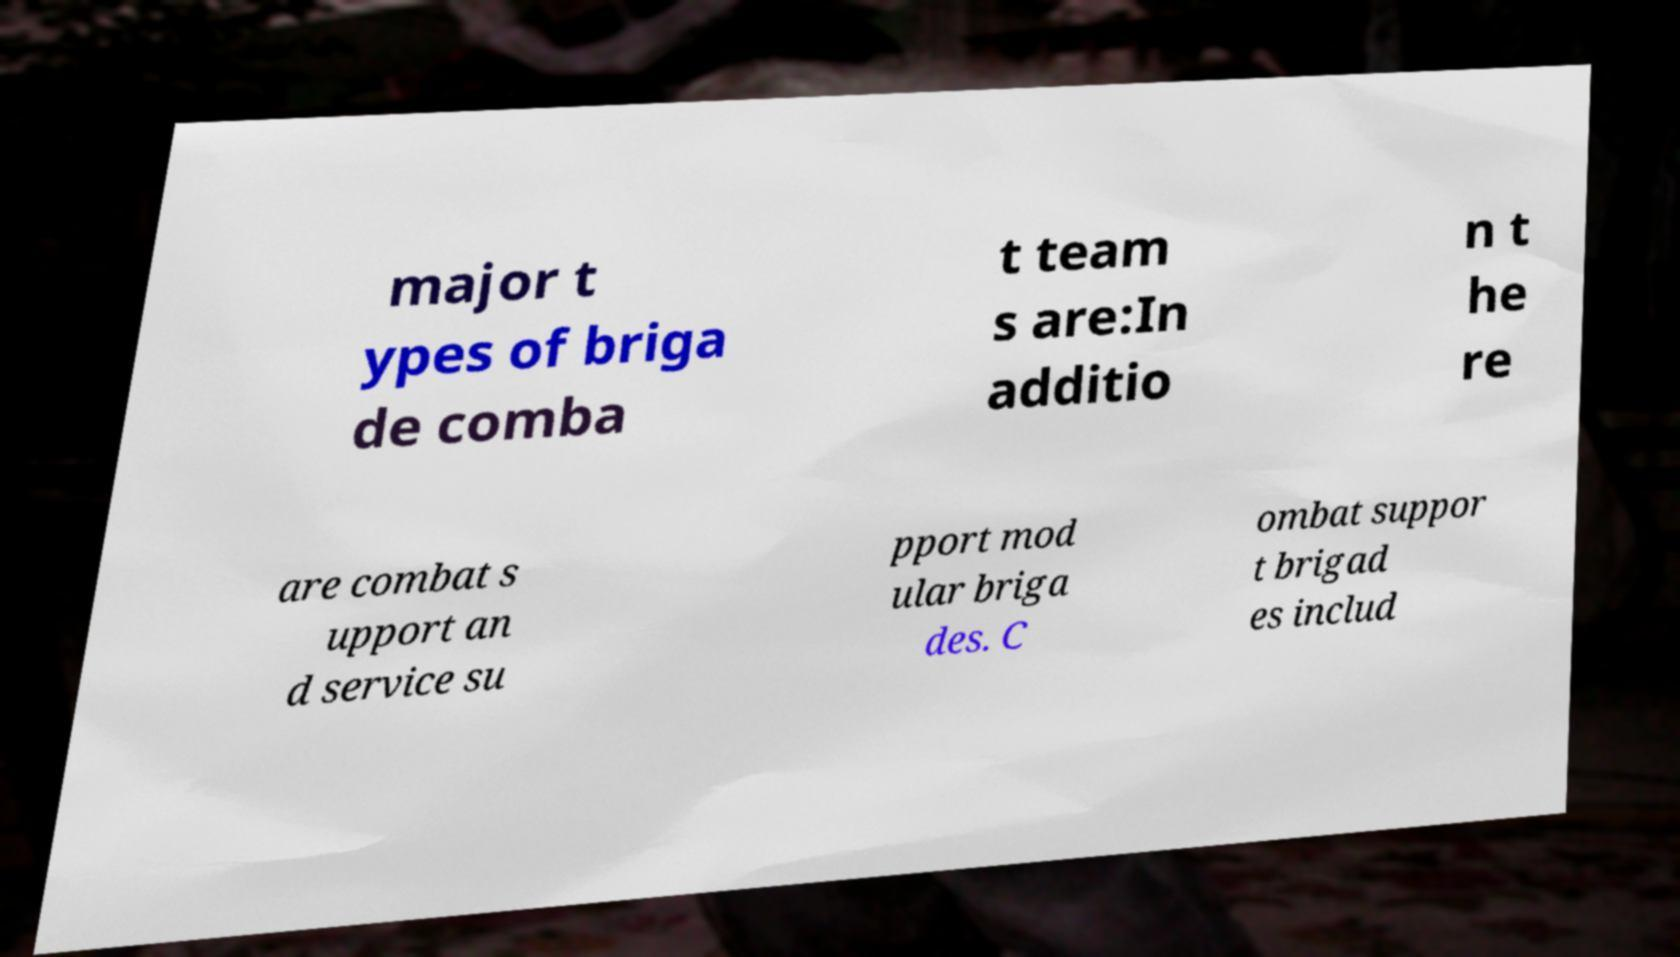Could you extract and type out the text from this image? major t ypes of briga de comba t team s are:In additio n t he re are combat s upport an d service su pport mod ular briga des. C ombat suppor t brigad es includ 